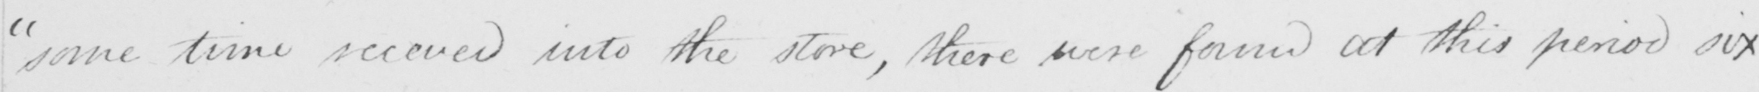Please provide the text content of this handwritten line. some time secured into the store , there were found at this period six 